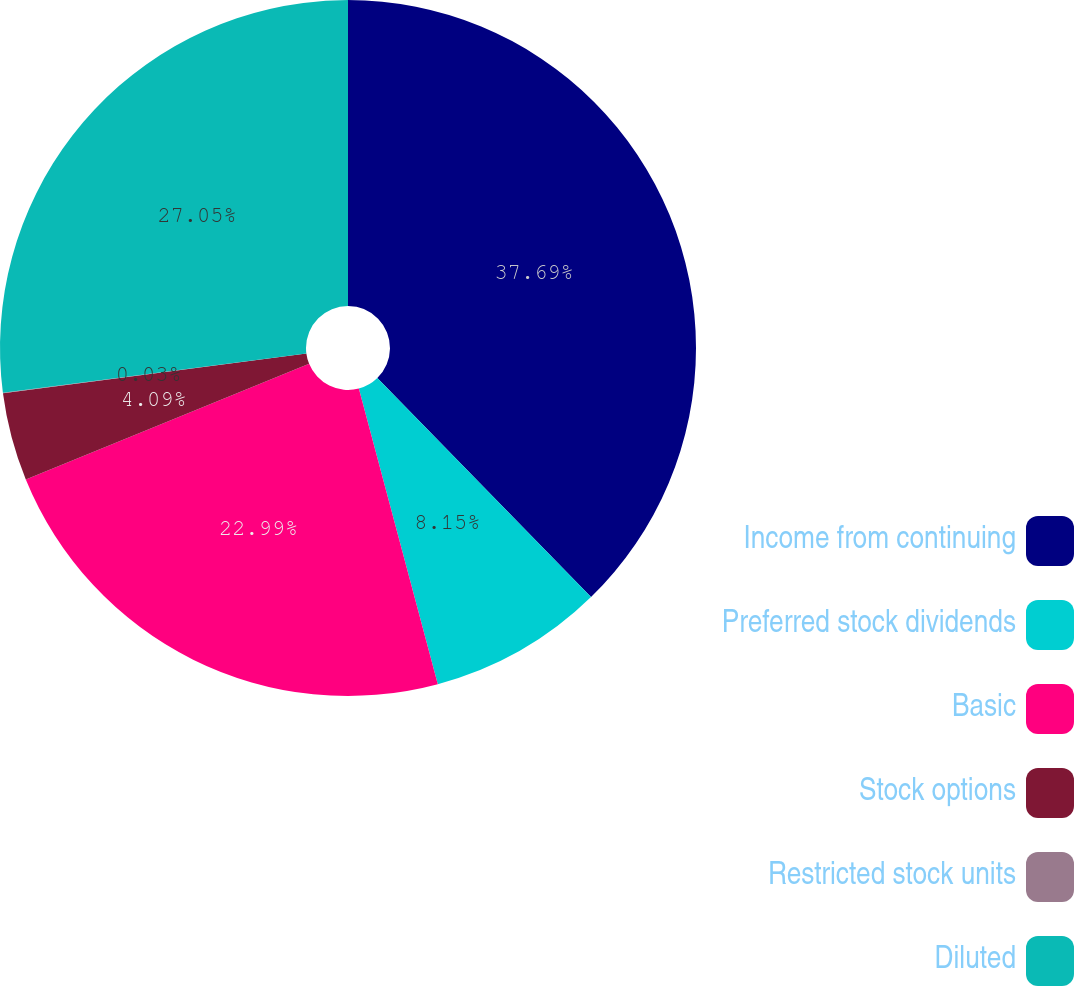Convert chart. <chart><loc_0><loc_0><loc_500><loc_500><pie_chart><fcel>Income from continuing<fcel>Preferred stock dividends<fcel>Basic<fcel>Stock options<fcel>Restricted stock units<fcel>Diluted<nl><fcel>37.7%<fcel>8.15%<fcel>22.99%<fcel>4.09%<fcel>0.03%<fcel>27.05%<nl></chart> 